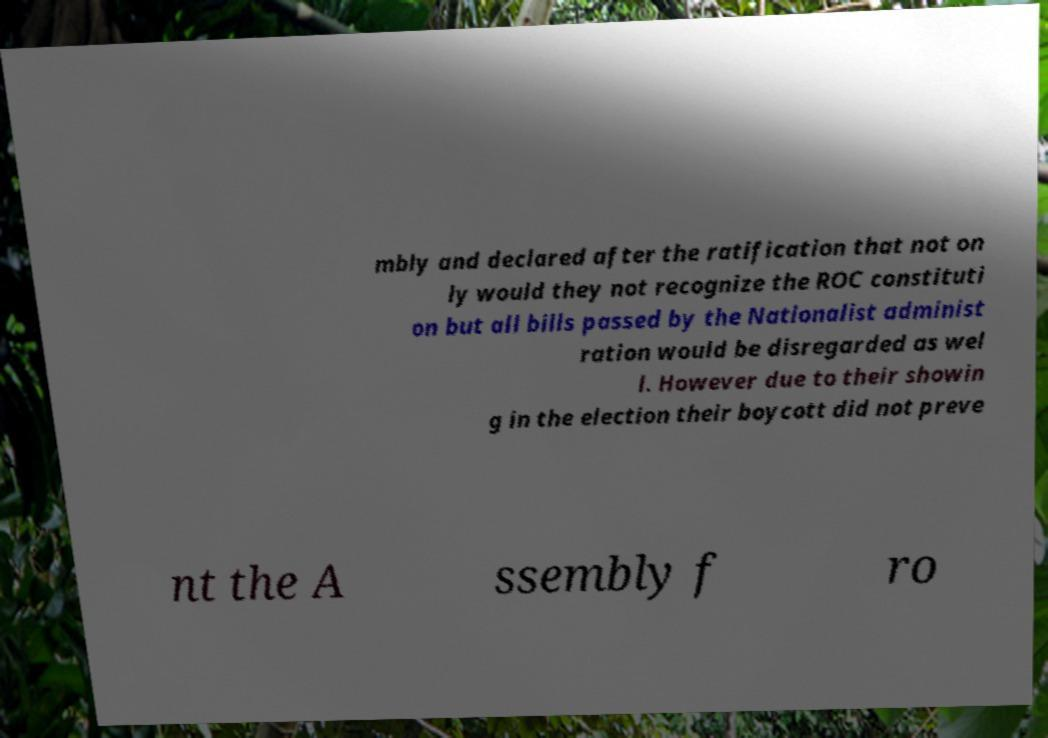I need the written content from this picture converted into text. Can you do that? mbly and declared after the ratification that not on ly would they not recognize the ROC constituti on but all bills passed by the Nationalist administ ration would be disregarded as wel l. However due to their showin g in the election their boycott did not preve nt the A ssembly f ro 